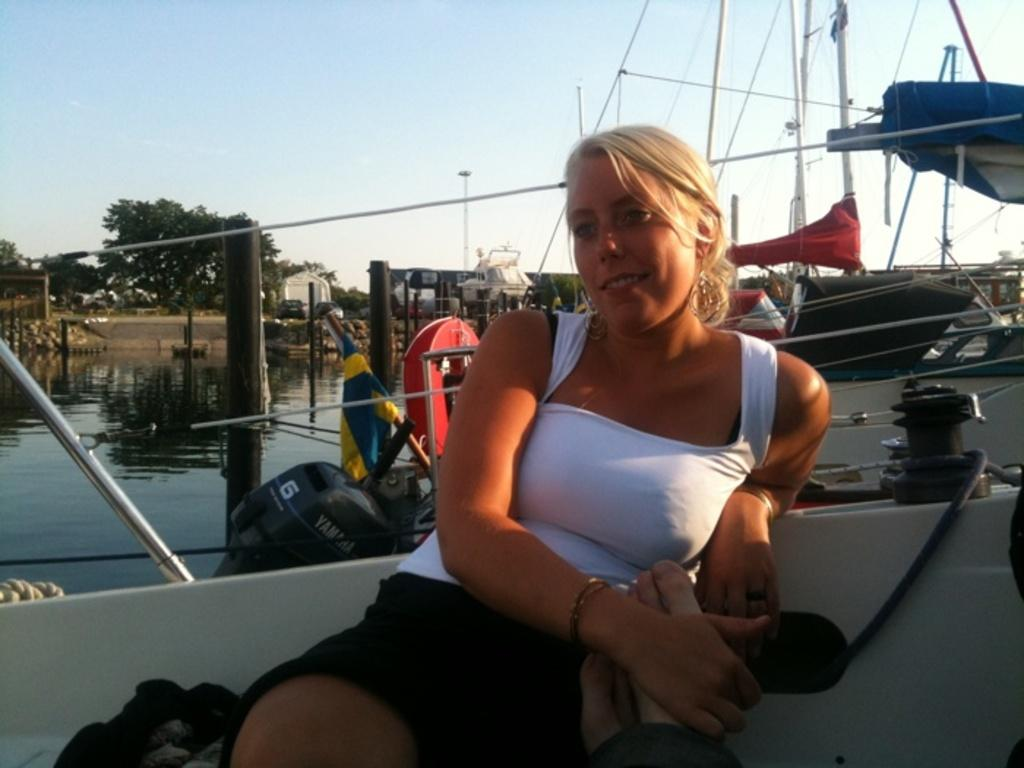What is the main subject in the foreground of the image? There is a woman in a boat in the foreground of the image. What can be seen in the background of the image? There are boats in the water, trees, houses, and the sky visible in the background of the image. What is the weather like in the image? The image appears to have been taken on a sunny day. What type of society is depicted in the image? The image does not depict a society; it shows a woman in a boat and various background elements. Are there any bears visible in the image? No, there are no bears present in the image. 